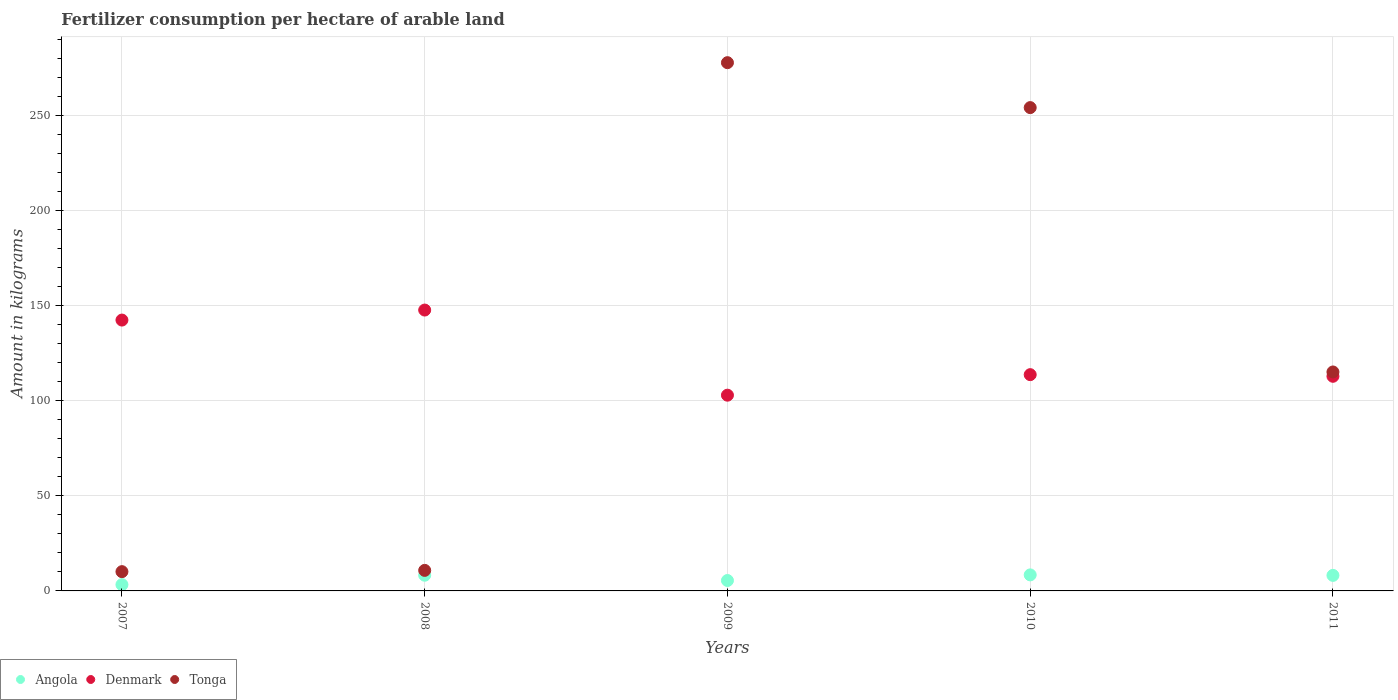How many different coloured dotlines are there?
Provide a succinct answer. 3. Is the number of dotlines equal to the number of legend labels?
Keep it short and to the point. Yes. What is the amount of fertilizer consumption in Denmark in 2010?
Give a very brief answer. 113.71. Across all years, what is the maximum amount of fertilizer consumption in Denmark?
Provide a succinct answer. 147.68. Across all years, what is the minimum amount of fertilizer consumption in Tonga?
Ensure brevity in your answer.  10.13. In which year was the amount of fertilizer consumption in Tonga minimum?
Offer a terse response. 2007. What is the total amount of fertilizer consumption in Denmark in the graph?
Provide a succinct answer. 619.57. What is the difference between the amount of fertilizer consumption in Angola in 2009 and that in 2011?
Offer a terse response. -2.7. What is the difference between the amount of fertilizer consumption in Angola in 2011 and the amount of fertilizer consumption in Denmark in 2008?
Provide a succinct answer. -139.51. What is the average amount of fertilizer consumption in Tonga per year?
Offer a terse response. 133.59. In the year 2011, what is the difference between the amount of fertilizer consumption in Tonga and amount of fertilizer consumption in Angola?
Offer a terse response. 106.96. What is the ratio of the amount of fertilizer consumption in Angola in 2007 to that in 2009?
Your response must be concise. 0.6. What is the difference between the highest and the second highest amount of fertilizer consumption in Tonga?
Provide a succinct answer. 23.62. What is the difference between the highest and the lowest amount of fertilizer consumption in Tonga?
Keep it short and to the point. 267.62. Is the sum of the amount of fertilizer consumption in Angola in 2007 and 2010 greater than the maximum amount of fertilizer consumption in Tonga across all years?
Keep it short and to the point. No. Does the amount of fertilizer consumption in Denmark monotonically increase over the years?
Provide a succinct answer. No. Is the amount of fertilizer consumption in Angola strictly greater than the amount of fertilizer consumption in Tonga over the years?
Your response must be concise. No. Are the values on the major ticks of Y-axis written in scientific E-notation?
Make the answer very short. No. Does the graph contain any zero values?
Offer a very short reply. No. Does the graph contain grids?
Offer a very short reply. Yes. What is the title of the graph?
Give a very brief answer. Fertilizer consumption per hectare of arable land. Does "Costa Rica" appear as one of the legend labels in the graph?
Your answer should be compact. No. What is the label or title of the Y-axis?
Your response must be concise. Amount in kilograms. What is the Amount in kilograms in Angola in 2007?
Offer a very short reply. 3.31. What is the Amount in kilograms of Denmark in 2007?
Your answer should be compact. 142.41. What is the Amount in kilograms of Tonga in 2007?
Provide a succinct answer. 10.13. What is the Amount in kilograms of Angola in 2008?
Make the answer very short. 8.26. What is the Amount in kilograms of Denmark in 2008?
Make the answer very short. 147.68. What is the Amount in kilograms in Angola in 2009?
Your response must be concise. 5.47. What is the Amount in kilograms of Denmark in 2009?
Your answer should be very brief. 102.92. What is the Amount in kilograms of Tonga in 2009?
Your answer should be very brief. 277.75. What is the Amount in kilograms of Angola in 2010?
Offer a very short reply. 8.43. What is the Amount in kilograms in Denmark in 2010?
Your response must be concise. 113.71. What is the Amount in kilograms in Tonga in 2010?
Your answer should be very brief. 254.12. What is the Amount in kilograms of Angola in 2011?
Keep it short and to the point. 8.17. What is the Amount in kilograms in Denmark in 2011?
Offer a terse response. 112.85. What is the Amount in kilograms in Tonga in 2011?
Ensure brevity in your answer.  115.12. Across all years, what is the maximum Amount in kilograms of Angola?
Offer a very short reply. 8.43. Across all years, what is the maximum Amount in kilograms in Denmark?
Give a very brief answer. 147.68. Across all years, what is the maximum Amount in kilograms of Tonga?
Make the answer very short. 277.75. Across all years, what is the minimum Amount in kilograms of Angola?
Your answer should be very brief. 3.31. Across all years, what is the minimum Amount in kilograms in Denmark?
Provide a succinct answer. 102.92. Across all years, what is the minimum Amount in kilograms in Tonga?
Provide a succinct answer. 10.13. What is the total Amount in kilograms in Angola in the graph?
Ensure brevity in your answer.  33.63. What is the total Amount in kilograms in Denmark in the graph?
Your response must be concise. 619.57. What is the total Amount in kilograms in Tonga in the graph?
Give a very brief answer. 667.93. What is the difference between the Amount in kilograms in Angola in 2007 and that in 2008?
Offer a terse response. -4.95. What is the difference between the Amount in kilograms of Denmark in 2007 and that in 2008?
Your response must be concise. -5.26. What is the difference between the Amount in kilograms in Angola in 2007 and that in 2009?
Your answer should be very brief. -2.17. What is the difference between the Amount in kilograms in Denmark in 2007 and that in 2009?
Ensure brevity in your answer.  39.49. What is the difference between the Amount in kilograms in Tonga in 2007 and that in 2009?
Offer a terse response. -267.62. What is the difference between the Amount in kilograms of Angola in 2007 and that in 2010?
Your response must be concise. -5.12. What is the difference between the Amount in kilograms in Denmark in 2007 and that in 2010?
Provide a succinct answer. 28.7. What is the difference between the Amount in kilograms in Tonga in 2007 and that in 2010?
Your response must be concise. -243.99. What is the difference between the Amount in kilograms in Angola in 2007 and that in 2011?
Your answer should be very brief. -4.86. What is the difference between the Amount in kilograms in Denmark in 2007 and that in 2011?
Offer a terse response. 29.56. What is the difference between the Amount in kilograms of Tonga in 2007 and that in 2011?
Give a very brief answer. -104.99. What is the difference between the Amount in kilograms of Angola in 2008 and that in 2009?
Offer a terse response. 2.79. What is the difference between the Amount in kilograms of Denmark in 2008 and that in 2009?
Ensure brevity in your answer.  44.76. What is the difference between the Amount in kilograms of Tonga in 2008 and that in 2009?
Provide a succinct answer. -266.95. What is the difference between the Amount in kilograms in Angola in 2008 and that in 2010?
Offer a very short reply. -0.17. What is the difference between the Amount in kilograms in Denmark in 2008 and that in 2010?
Your response must be concise. 33.96. What is the difference between the Amount in kilograms in Tonga in 2008 and that in 2010?
Offer a very short reply. -243.32. What is the difference between the Amount in kilograms of Angola in 2008 and that in 2011?
Ensure brevity in your answer.  0.09. What is the difference between the Amount in kilograms in Denmark in 2008 and that in 2011?
Your response must be concise. 34.83. What is the difference between the Amount in kilograms of Tonga in 2008 and that in 2011?
Your response must be concise. -104.33. What is the difference between the Amount in kilograms of Angola in 2009 and that in 2010?
Your response must be concise. -2.96. What is the difference between the Amount in kilograms in Denmark in 2009 and that in 2010?
Your response must be concise. -10.79. What is the difference between the Amount in kilograms in Tonga in 2009 and that in 2010?
Ensure brevity in your answer.  23.62. What is the difference between the Amount in kilograms of Angola in 2009 and that in 2011?
Provide a short and direct response. -2.7. What is the difference between the Amount in kilograms of Denmark in 2009 and that in 2011?
Give a very brief answer. -9.93. What is the difference between the Amount in kilograms of Tonga in 2009 and that in 2011?
Provide a succinct answer. 162.62. What is the difference between the Amount in kilograms in Angola in 2010 and that in 2011?
Provide a succinct answer. 0.26. What is the difference between the Amount in kilograms of Denmark in 2010 and that in 2011?
Provide a succinct answer. 0.86. What is the difference between the Amount in kilograms of Tonga in 2010 and that in 2011?
Your response must be concise. 139. What is the difference between the Amount in kilograms of Angola in 2007 and the Amount in kilograms of Denmark in 2008?
Your response must be concise. -144.37. What is the difference between the Amount in kilograms in Angola in 2007 and the Amount in kilograms in Tonga in 2008?
Your answer should be compact. -7.5. What is the difference between the Amount in kilograms of Denmark in 2007 and the Amount in kilograms of Tonga in 2008?
Your answer should be very brief. 131.61. What is the difference between the Amount in kilograms in Angola in 2007 and the Amount in kilograms in Denmark in 2009?
Ensure brevity in your answer.  -99.61. What is the difference between the Amount in kilograms of Angola in 2007 and the Amount in kilograms of Tonga in 2009?
Ensure brevity in your answer.  -274.44. What is the difference between the Amount in kilograms in Denmark in 2007 and the Amount in kilograms in Tonga in 2009?
Give a very brief answer. -135.34. What is the difference between the Amount in kilograms of Angola in 2007 and the Amount in kilograms of Denmark in 2010?
Your answer should be very brief. -110.41. What is the difference between the Amount in kilograms in Angola in 2007 and the Amount in kilograms in Tonga in 2010?
Offer a very short reply. -250.82. What is the difference between the Amount in kilograms of Denmark in 2007 and the Amount in kilograms of Tonga in 2010?
Offer a terse response. -111.71. What is the difference between the Amount in kilograms of Angola in 2007 and the Amount in kilograms of Denmark in 2011?
Your answer should be very brief. -109.54. What is the difference between the Amount in kilograms of Angola in 2007 and the Amount in kilograms of Tonga in 2011?
Your answer should be very brief. -111.82. What is the difference between the Amount in kilograms in Denmark in 2007 and the Amount in kilograms in Tonga in 2011?
Provide a short and direct response. 27.29. What is the difference between the Amount in kilograms in Angola in 2008 and the Amount in kilograms in Denmark in 2009?
Offer a terse response. -94.66. What is the difference between the Amount in kilograms of Angola in 2008 and the Amount in kilograms of Tonga in 2009?
Your answer should be compact. -269.49. What is the difference between the Amount in kilograms in Denmark in 2008 and the Amount in kilograms in Tonga in 2009?
Offer a very short reply. -130.07. What is the difference between the Amount in kilograms of Angola in 2008 and the Amount in kilograms of Denmark in 2010?
Provide a succinct answer. -105.45. What is the difference between the Amount in kilograms of Angola in 2008 and the Amount in kilograms of Tonga in 2010?
Provide a succinct answer. -245.87. What is the difference between the Amount in kilograms in Denmark in 2008 and the Amount in kilograms in Tonga in 2010?
Provide a short and direct response. -106.45. What is the difference between the Amount in kilograms of Angola in 2008 and the Amount in kilograms of Denmark in 2011?
Your answer should be compact. -104.59. What is the difference between the Amount in kilograms in Angola in 2008 and the Amount in kilograms in Tonga in 2011?
Make the answer very short. -106.87. What is the difference between the Amount in kilograms of Denmark in 2008 and the Amount in kilograms of Tonga in 2011?
Your answer should be very brief. 32.55. What is the difference between the Amount in kilograms of Angola in 2009 and the Amount in kilograms of Denmark in 2010?
Provide a short and direct response. -108.24. What is the difference between the Amount in kilograms of Angola in 2009 and the Amount in kilograms of Tonga in 2010?
Offer a terse response. -248.65. What is the difference between the Amount in kilograms of Denmark in 2009 and the Amount in kilograms of Tonga in 2010?
Offer a terse response. -151.21. What is the difference between the Amount in kilograms of Angola in 2009 and the Amount in kilograms of Denmark in 2011?
Give a very brief answer. -107.38. What is the difference between the Amount in kilograms in Angola in 2009 and the Amount in kilograms in Tonga in 2011?
Your response must be concise. -109.65. What is the difference between the Amount in kilograms in Denmark in 2009 and the Amount in kilograms in Tonga in 2011?
Provide a short and direct response. -12.21. What is the difference between the Amount in kilograms of Angola in 2010 and the Amount in kilograms of Denmark in 2011?
Give a very brief answer. -104.42. What is the difference between the Amount in kilograms of Angola in 2010 and the Amount in kilograms of Tonga in 2011?
Your answer should be compact. -106.69. What is the difference between the Amount in kilograms of Denmark in 2010 and the Amount in kilograms of Tonga in 2011?
Keep it short and to the point. -1.41. What is the average Amount in kilograms in Angola per year?
Offer a terse response. 6.73. What is the average Amount in kilograms of Denmark per year?
Give a very brief answer. 123.91. What is the average Amount in kilograms of Tonga per year?
Your answer should be compact. 133.59. In the year 2007, what is the difference between the Amount in kilograms of Angola and Amount in kilograms of Denmark?
Keep it short and to the point. -139.11. In the year 2007, what is the difference between the Amount in kilograms of Angola and Amount in kilograms of Tonga?
Your response must be concise. -6.83. In the year 2007, what is the difference between the Amount in kilograms of Denmark and Amount in kilograms of Tonga?
Provide a succinct answer. 132.28. In the year 2008, what is the difference between the Amount in kilograms of Angola and Amount in kilograms of Denmark?
Provide a short and direct response. -139.42. In the year 2008, what is the difference between the Amount in kilograms in Angola and Amount in kilograms in Tonga?
Your answer should be compact. -2.54. In the year 2008, what is the difference between the Amount in kilograms in Denmark and Amount in kilograms in Tonga?
Provide a succinct answer. 136.88. In the year 2009, what is the difference between the Amount in kilograms in Angola and Amount in kilograms in Denmark?
Keep it short and to the point. -97.45. In the year 2009, what is the difference between the Amount in kilograms in Angola and Amount in kilograms in Tonga?
Provide a short and direct response. -272.28. In the year 2009, what is the difference between the Amount in kilograms in Denmark and Amount in kilograms in Tonga?
Your response must be concise. -174.83. In the year 2010, what is the difference between the Amount in kilograms of Angola and Amount in kilograms of Denmark?
Ensure brevity in your answer.  -105.28. In the year 2010, what is the difference between the Amount in kilograms in Angola and Amount in kilograms in Tonga?
Provide a short and direct response. -245.69. In the year 2010, what is the difference between the Amount in kilograms in Denmark and Amount in kilograms in Tonga?
Keep it short and to the point. -140.41. In the year 2011, what is the difference between the Amount in kilograms of Angola and Amount in kilograms of Denmark?
Keep it short and to the point. -104.68. In the year 2011, what is the difference between the Amount in kilograms in Angola and Amount in kilograms in Tonga?
Keep it short and to the point. -106.96. In the year 2011, what is the difference between the Amount in kilograms of Denmark and Amount in kilograms of Tonga?
Your response must be concise. -2.28. What is the ratio of the Amount in kilograms of Angola in 2007 to that in 2008?
Your answer should be very brief. 0.4. What is the ratio of the Amount in kilograms in Denmark in 2007 to that in 2008?
Your answer should be very brief. 0.96. What is the ratio of the Amount in kilograms in Tonga in 2007 to that in 2008?
Keep it short and to the point. 0.94. What is the ratio of the Amount in kilograms of Angola in 2007 to that in 2009?
Give a very brief answer. 0.6. What is the ratio of the Amount in kilograms in Denmark in 2007 to that in 2009?
Keep it short and to the point. 1.38. What is the ratio of the Amount in kilograms in Tonga in 2007 to that in 2009?
Offer a very short reply. 0.04. What is the ratio of the Amount in kilograms of Angola in 2007 to that in 2010?
Your answer should be very brief. 0.39. What is the ratio of the Amount in kilograms of Denmark in 2007 to that in 2010?
Keep it short and to the point. 1.25. What is the ratio of the Amount in kilograms in Tonga in 2007 to that in 2010?
Provide a succinct answer. 0.04. What is the ratio of the Amount in kilograms of Angola in 2007 to that in 2011?
Make the answer very short. 0.4. What is the ratio of the Amount in kilograms of Denmark in 2007 to that in 2011?
Provide a short and direct response. 1.26. What is the ratio of the Amount in kilograms in Tonga in 2007 to that in 2011?
Provide a short and direct response. 0.09. What is the ratio of the Amount in kilograms in Angola in 2008 to that in 2009?
Give a very brief answer. 1.51. What is the ratio of the Amount in kilograms of Denmark in 2008 to that in 2009?
Offer a very short reply. 1.43. What is the ratio of the Amount in kilograms of Tonga in 2008 to that in 2009?
Give a very brief answer. 0.04. What is the ratio of the Amount in kilograms in Angola in 2008 to that in 2010?
Keep it short and to the point. 0.98. What is the ratio of the Amount in kilograms of Denmark in 2008 to that in 2010?
Your answer should be compact. 1.3. What is the ratio of the Amount in kilograms in Tonga in 2008 to that in 2010?
Offer a terse response. 0.04. What is the ratio of the Amount in kilograms in Angola in 2008 to that in 2011?
Keep it short and to the point. 1.01. What is the ratio of the Amount in kilograms of Denmark in 2008 to that in 2011?
Ensure brevity in your answer.  1.31. What is the ratio of the Amount in kilograms in Tonga in 2008 to that in 2011?
Ensure brevity in your answer.  0.09. What is the ratio of the Amount in kilograms in Angola in 2009 to that in 2010?
Your answer should be compact. 0.65. What is the ratio of the Amount in kilograms in Denmark in 2009 to that in 2010?
Give a very brief answer. 0.91. What is the ratio of the Amount in kilograms in Tonga in 2009 to that in 2010?
Make the answer very short. 1.09. What is the ratio of the Amount in kilograms of Angola in 2009 to that in 2011?
Your answer should be compact. 0.67. What is the ratio of the Amount in kilograms in Denmark in 2009 to that in 2011?
Offer a terse response. 0.91. What is the ratio of the Amount in kilograms in Tonga in 2009 to that in 2011?
Give a very brief answer. 2.41. What is the ratio of the Amount in kilograms in Angola in 2010 to that in 2011?
Keep it short and to the point. 1.03. What is the ratio of the Amount in kilograms in Denmark in 2010 to that in 2011?
Offer a very short reply. 1.01. What is the ratio of the Amount in kilograms of Tonga in 2010 to that in 2011?
Provide a succinct answer. 2.21. What is the difference between the highest and the second highest Amount in kilograms of Angola?
Offer a very short reply. 0.17. What is the difference between the highest and the second highest Amount in kilograms of Denmark?
Provide a succinct answer. 5.26. What is the difference between the highest and the second highest Amount in kilograms in Tonga?
Offer a very short reply. 23.62. What is the difference between the highest and the lowest Amount in kilograms of Angola?
Make the answer very short. 5.12. What is the difference between the highest and the lowest Amount in kilograms of Denmark?
Your response must be concise. 44.76. What is the difference between the highest and the lowest Amount in kilograms of Tonga?
Keep it short and to the point. 267.62. 